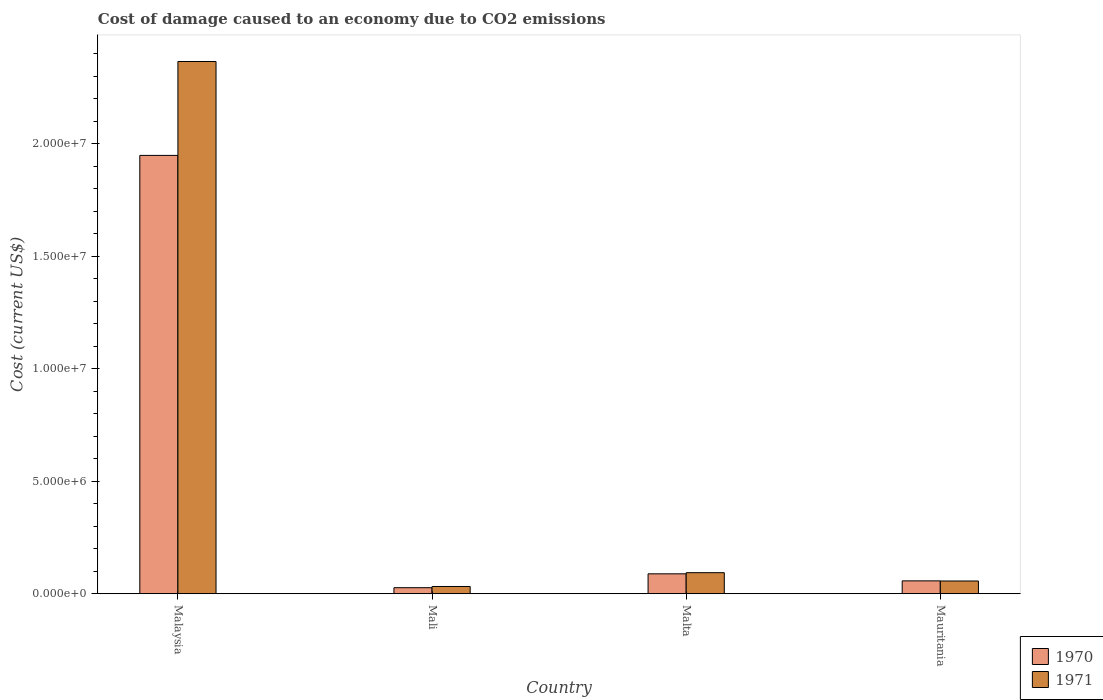How many bars are there on the 4th tick from the left?
Provide a short and direct response. 2. How many bars are there on the 1st tick from the right?
Your answer should be compact. 2. What is the label of the 3rd group of bars from the left?
Offer a very short reply. Malta. What is the cost of damage caused due to CO2 emissisons in 1970 in Malaysia?
Your answer should be compact. 1.95e+07. Across all countries, what is the maximum cost of damage caused due to CO2 emissisons in 1971?
Ensure brevity in your answer.  2.37e+07. Across all countries, what is the minimum cost of damage caused due to CO2 emissisons in 1970?
Your answer should be very brief. 2.69e+05. In which country was the cost of damage caused due to CO2 emissisons in 1971 maximum?
Keep it short and to the point. Malaysia. In which country was the cost of damage caused due to CO2 emissisons in 1970 minimum?
Offer a terse response. Mali. What is the total cost of damage caused due to CO2 emissisons in 1971 in the graph?
Keep it short and to the point. 2.55e+07. What is the difference between the cost of damage caused due to CO2 emissisons in 1971 in Malta and that in Mauritania?
Make the answer very short. 3.69e+05. What is the difference between the cost of damage caused due to CO2 emissisons in 1971 in Malta and the cost of damage caused due to CO2 emissisons in 1970 in Malaysia?
Offer a very short reply. -1.86e+07. What is the average cost of damage caused due to CO2 emissisons in 1970 per country?
Give a very brief answer. 5.30e+06. What is the difference between the cost of damage caused due to CO2 emissisons of/in 1970 and cost of damage caused due to CO2 emissisons of/in 1971 in Malaysia?
Provide a succinct answer. -4.18e+06. What is the ratio of the cost of damage caused due to CO2 emissisons in 1970 in Malaysia to that in Malta?
Provide a succinct answer. 22. What is the difference between the highest and the second highest cost of damage caused due to CO2 emissisons in 1970?
Provide a succinct answer. -1.86e+07. What is the difference between the highest and the lowest cost of damage caused due to CO2 emissisons in 1971?
Make the answer very short. 2.33e+07. In how many countries, is the cost of damage caused due to CO2 emissisons in 1971 greater than the average cost of damage caused due to CO2 emissisons in 1971 taken over all countries?
Your answer should be very brief. 1. Is the sum of the cost of damage caused due to CO2 emissisons in 1970 in Malaysia and Malta greater than the maximum cost of damage caused due to CO2 emissisons in 1971 across all countries?
Make the answer very short. No. What does the 1st bar from the left in Malta represents?
Your answer should be compact. 1970. How many countries are there in the graph?
Provide a succinct answer. 4. Are the values on the major ticks of Y-axis written in scientific E-notation?
Keep it short and to the point. Yes. How many legend labels are there?
Provide a succinct answer. 2. How are the legend labels stacked?
Your response must be concise. Vertical. What is the title of the graph?
Provide a short and direct response. Cost of damage caused to an economy due to CO2 emissions. What is the label or title of the X-axis?
Make the answer very short. Country. What is the label or title of the Y-axis?
Provide a succinct answer. Cost (current US$). What is the Cost (current US$) in 1970 in Malaysia?
Make the answer very short. 1.95e+07. What is the Cost (current US$) of 1971 in Malaysia?
Provide a succinct answer. 2.37e+07. What is the Cost (current US$) in 1970 in Mali?
Give a very brief answer. 2.69e+05. What is the Cost (current US$) of 1971 in Mali?
Offer a very short reply. 3.23e+05. What is the Cost (current US$) of 1970 in Malta?
Keep it short and to the point. 8.86e+05. What is the Cost (current US$) of 1971 in Malta?
Provide a short and direct response. 9.37e+05. What is the Cost (current US$) in 1970 in Mauritania?
Your answer should be compact. 5.73e+05. What is the Cost (current US$) in 1971 in Mauritania?
Your answer should be very brief. 5.67e+05. Across all countries, what is the maximum Cost (current US$) in 1970?
Your answer should be compact. 1.95e+07. Across all countries, what is the maximum Cost (current US$) in 1971?
Offer a very short reply. 2.37e+07. Across all countries, what is the minimum Cost (current US$) of 1970?
Provide a short and direct response. 2.69e+05. Across all countries, what is the minimum Cost (current US$) of 1971?
Give a very brief answer. 3.23e+05. What is the total Cost (current US$) of 1970 in the graph?
Ensure brevity in your answer.  2.12e+07. What is the total Cost (current US$) of 1971 in the graph?
Ensure brevity in your answer.  2.55e+07. What is the difference between the Cost (current US$) of 1970 in Malaysia and that in Mali?
Provide a short and direct response. 1.92e+07. What is the difference between the Cost (current US$) of 1971 in Malaysia and that in Mali?
Offer a very short reply. 2.33e+07. What is the difference between the Cost (current US$) in 1970 in Malaysia and that in Malta?
Ensure brevity in your answer.  1.86e+07. What is the difference between the Cost (current US$) in 1971 in Malaysia and that in Malta?
Provide a short and direct response. 2.27e+07. What is the difference between the Cost (current US$) in 1970 in Malaysia and that in Mauritania?
Offer a very short reply. 1.89e+07. What is the difference between the Cost (current US$) of 1971 in Malaysia and that in Mauritania?
Provide a succinct answer. 2.31e+07. What is the difference between the Cost (current US$) in 1970 in Mali and that in Malta?
Your answer should be very brief. -6.17e+05. What is the difference between the Cost (current US$) of 1971 in Mali and that in Malta?
Provide a succinct answer. -6.14e+05. What is the difference between the Cost (current US$) of 1970 in Mali and that in Mauritania?
Offer a terse response. -3.03e+05. What is the difference between the Cost (current US$) in 1971 in Mali and that in Mauritania?
Your answer should be very brief. -2.45e+05. What is the difference between the Cost (current US$) of 1970 in Malta and that in Mauritania?
Keep it short and to the point. 3.13e+05. What is the difference between the Cost (current US$) of 1971 in Malta and that in Mauritania?
Offer a very short reply. 3.69e+05. What is the difference between the Cost (current US$) of 1970 in Malaysia and the Cost (current US$) of 1971 in Mali?
Offer a very short reply. 1.92e+07. What is the difference between the Cost (current US$) of 1970 in Malaysia and the Cost (current US$) of 1971 in Malta?
Keep it short and to the point. 1.86e+07. What is the difference between the Cost (current US$) of 1970 in Malaysia and the Cost (current US$) of 1971 in Mauritania?
Offer a very short reply. 1.89e+07. What is the difference between the Cost (current US$) of 1970 in Mali and the Cost (current US$) of 1971 in Malta?
Offer a terse response. -6.67e+05. What is the difference between the Cost (current US$) of 1970 in Mali and the Cost (current US$) of 1971 in Mauritania?
Keep it short and to the point. -2.98e+05. What is the difference between the Cost (current US$) of 1970 in Malta and the Cost (current US$) of 1971 in Mauritania?
Your answer should be compact. 3.19e+05. What is the average Cost (current US$) in 1970 per country?
Provide a short and direct response. 5.30e+06. What is the average Cost (current US$) in 1971 per country?
Offer a very short reply. 6.37e+06. What is the difference between the Cost (current US$) in 1970 and Cost (current US$) in 1971 in Malaysia?
Ensure brevity in your answer.  -4.18e+06. What is the difference between the Cost (current US$) in 1970 and Cost (current US$) in 1971 in Mali?
Offer a very short reply. -5.34e+04. What is the difference between the Cost (current US$) in 1970 and Cost (current US$) in 1971 in Malta?
Give a very brief answer. -5.07e+04. What is the difference between the Cost (current US$) of 1970 and Cost (current US$) of 1971 in Mauritania?
Your answer should be very brief. 5478.06. What is the ratio of the Cost (current US$) in 1970 in Malaysia to that in Mali?
Provide a short and direct response. 72.4. What is the ratio of the Cost (current US$) of 1971 in Malaysia to that in Mali?
Offer a very short reply. 73.35. What is the ratio of the Cost (current US$) in 1971 in Malaysia to that in Malta?
Your response must be concise. 25.27. What is the ratio of the Cost (current US$) of 1970 in Malaysia to that in Mauritania?
Provide a short and direct response. 34.03. What is the ratio of the Cost (current US$) of 1971 in Malaysia to that in Mauritania?
Give a very brief answer. 41.72. What is the ratio of the Cost (current US$) in 1970 in Mali to that in Malta?
Offer a very short reply. 0.3. What is the ratio of the Cost (current US$) in 1971 in Mali to that in Malta?
Offer a terse response. 0.34. What is the ratio of the Cost (current US$) of 1970 in Mali to that in Mauritania?
Provide a short and direct response. 0.47. What is the ratio of the Cost (current US$) of 1971 in Mali to that in Mauritania?
Give a very brief answer. 0.57. What is the ratio of the Cost (current US$) in 1970 in Malta to that in Mauritania?
Your response must be concise. 1.55. What is the ratio of the Cost (current US$) in 1971 in Malta to that in Mauritania?
Keep it short and to the point. 1.65. What is the difference between the highest and the second highest Cost (current US$) in 1970?
Offer a terse response. 1.86e+07. What is the difference between the highest and the second highest Cost (current US$) in 1971?
Offer a terse response. 2.27e+07. What is the difference between the highest and the lowest Cost (current US$) in 1970?
Your response must be concise. 1.92e+07. What is the difference between the highest and the lowest Cost (current US$) in 1971?
Keep it short and to the point. 2.33e+07. 